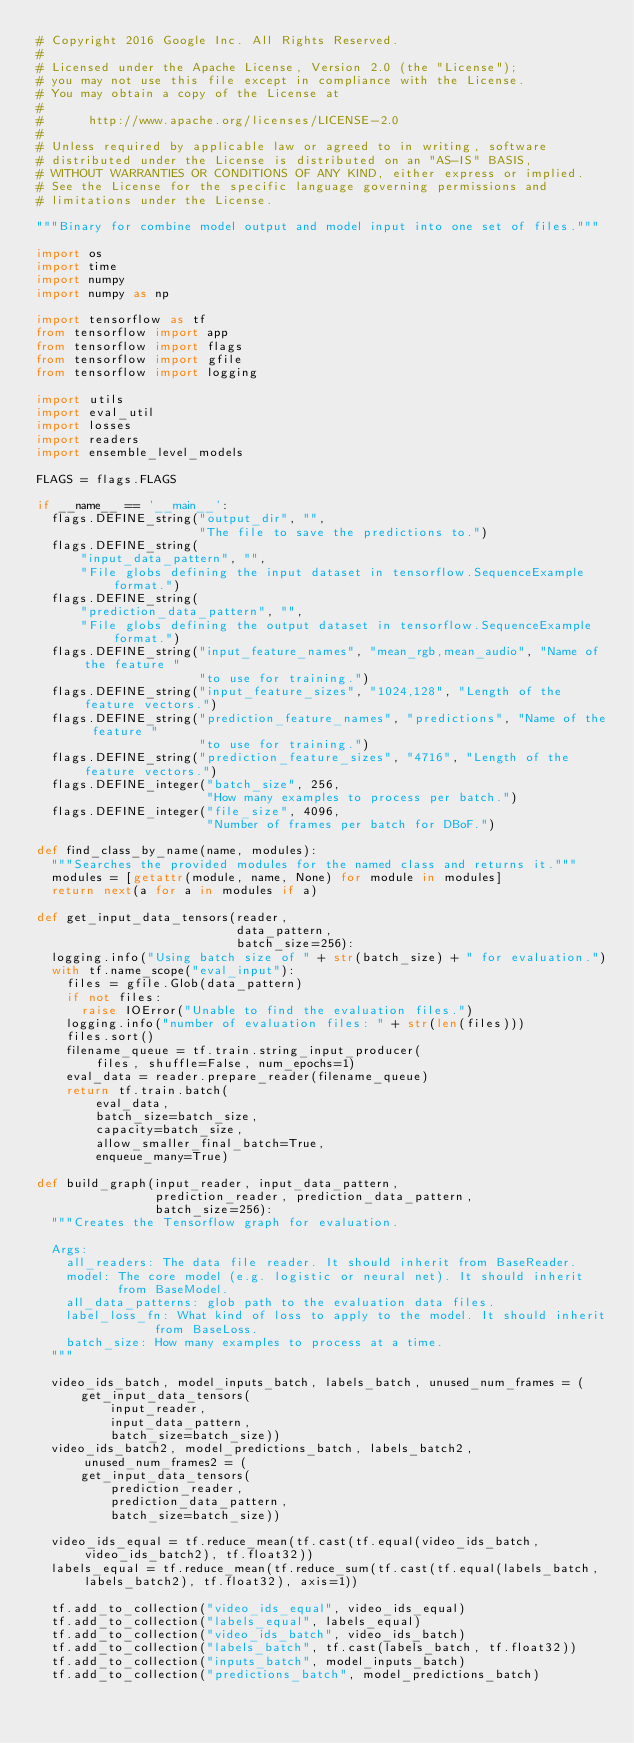<code> <loc_0><loc_0><loc_500><loc_500><_Python_># Copyright 2016 Google Inc. All Rights Reserved.
#
# Licensed under the Apache License, Version 2.0 (the "License");
# you may not use this file except in compliance with the License.
# You may obtain a copy of the License at
#
#      http://www.apache.org/licenses/LICENSE-2.0
#
# Unless required by applicable law or agreed to in writing, software
# distributed under the License is distributed on an "AS-IS" BASIS,
# WITHOUT WARRANTIES OR CONDITIONS OF ANY KIND, either express or implied.
# See the License for the specific language governing permissions and
# limitations under the License.

"""Binary for combine model output and model input into one set of files."""

import os
import time
import numpy
import numpy as np

import tensorflow as tf
from tensorflow import app
from tensorflow import flags
from tensorflow import gfile
from tensorflow import logging

import utils
import eval_util
import losses
import readers
import ensemble_level_models

FLAGS = flags.FLAGS

if __name__ == '__main__':
  flags.DEFINE_string("output_dir", "",
                      "The file to save the predictions to.")
  flags.DEFINE_string(
      "input_data_pattern", "",
      "File globs defining the input dataset in tensorflow.SequenceExample format.")
  flags.DEFINE_string(
      "prediction_data_pattern", "",
      "File globs defining the output dataset in tensorflow.SequenceExample format.")
  flags.DEFINE_string("input_feature_names", "mean_rgb,mean_audio", "Name of the feature "
                      "to use for training.")
  flags.DEFINE_string("input_feature_sizes", "1024,128", "Length of the feature vectors.")
  flags.DEFINE_string("prediction_feature_names", "predictions", "Name of the feature "
                      "to use for training.")
  flags.DEFINE_string("prediction_feature_sizes", "4716", "Length of the feature vectors.")
  flags.DEFINE_integer("batch_size", 256,
                       "How many examples to process per batch.")
  flags.DEFINE_integer("file_size", 4096,
                       "Number of frames per batch for DBoF.")

def find_class_by_name(name, modules):
  """Searches the provided modules for the named class and returns it."""
  modules = [getattr(module, name, None) for module in modules]
  return next(a for a in modules if a)

def get_input_data_tensors(reader,
                           data_pattern,
                           batch_size=256):
  logging.info("Using batch size of " + str(batch_size) + " for evaluation.")
  with tf.name_scope("eval_input"):
    files = gfile.Glob(data_pattern)
    if not files:
      raise IOError("Unable to find the evaluation files.")
    logging.info("number of evaluation files: " + str(len(files)))
    files.sort()
    filename_queue = tf.train.string_input_producer(
        files, shuffle=False, num_epochs=1)
    eval_data = reader.prepare_reader(filename_queue)
    return tf.train.batch(
        eval_data,
        batch_size=batch_size,
        capacity=batch_size,
        allow_smaller_final_batch=True,
        enqueue_many=True)

def build_graph(input_reader, input_data_pattern,
                prediction_reader, prediction_data_pattern,
                batch_size=256):
  """Creates the Tensorflow graph for evaluation.

  Args:
    all_readers: The data file reader. It should inherit from BaseReader.
    model: The core model (e.g. logistic or neural net). It should inherit
           from BaseModel.
    all_data_patterns: glob path to the evaluation data files.
    label_loss_fn: What kind of loss to apply to the model. It should inherit
                from BaseLoss.
    batch_size: How many examples to process at a time.
  """

  video_ids_batch, model_inputs_batch, labels_batch, unused_num_frames = (
      get_input_data_tensors(
          input_reader,
          input_data_pattern,
          batch_size=batch_size))
  video_ids_batch2, model_predictions_batch, labels_batch2, unused_num_frames2 = (
      get_input_data_tensors(
          prediction_reader,
          prediction_data_pattern,
          batch_size=batch_size))

  video_ids_equal = tf.reduce_mean(tf.cast(tf.equal(video_ids_batch, video_ids_batch2), tf.float32))
  labels_equal = tf.reduce_mean(tf.reduce_sum(tf.cast(tf.equal(labels_batch, labels_batch2), tf.float32), axis=1))

  tf.add_to_collection("video_ids_equal", video_ids_equal)
  tf.add_to_collection("labels_equal", labels_equal)
  tf.add_to_collection("video_ids_batch", video_ids_batch)
  tf.add_to_collection("labels_batch", tf.cast(labels_batch, tf.float32))
  tf.add_to_collection("inputs_batch", model_inputs_batch)
  tf.add_to_collection("predictions_batch", model_predictions_batch)

</code> 